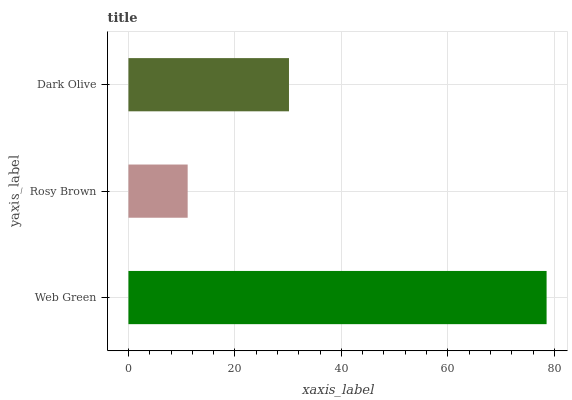Is Rosy Brown the minimum?
Answer yes or no. Yes. Is Web Green the maximum?
Answer yes or no. Yes. Is Dark Olive the minimum?
Answer yes or no. No. Is Dark Olive the maximum?
Answer yes or no. No. Is Dark Olive greater than Rosy Brown?
Answer yes or no. Yes. Is Rosy Brown less than Dark Olive?
Answer yes or no. Yes. Is Rosy Brown greater than Dark Olive?
Answer yes or no. No. Is Dark Olive less than Rosy Brown?
Answer yes or no. No. Is Dark Olive the high median?
Answer yes or no. Yes. Is Dark Olive the low median?
Answer yes or no. Yes. Is Rosy Brown the high median?
Answer yes or no. No. Is Web Green the low median?
Answer yes or no. No. 